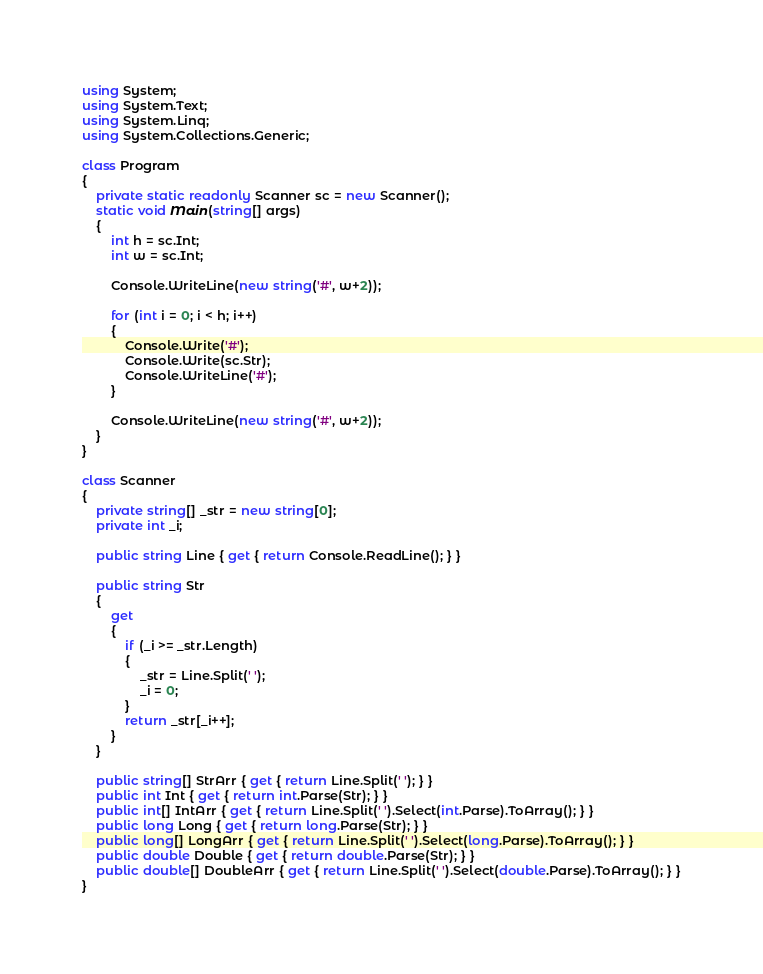<code> <loc_0><loc_0><loc_500><loc_500><_C#_>using System;
using System.Text;
using System.Linq;
using System.Collections.Generic;

class Program
{
    private static readonly Scanner sc = new Scanner();
    static void Main(string[] args)
    {
        int h = sc.Int;
        int w = sc.Int;

        Console.WriteLine(new string('#', w+2));

        for (int i = 0; i < h; i++)
        {
            Console.Write('#');
            Console.Write(sc.Str);
            Console.WriteLine('#');
        }

        Console.WriteLine(new string('#', w+2));
    }
}

class Scanner
{
    private string[] _str = new string[0];
    private int _i;

    public string Line { get { return Console.ReadLine(); } }

    public string Str
    {
        get
        {
            if (_i >= _str.Length)
            {
                _str = Line.Split(' ');
                _i = 0;
            }
            return _str[_i++];
        }
    }

    public string[] StrArr { get { return Line.Split(' '); } }
    public int Int { get { return int.Parse(Str); } }
    public int[] IntArr { get { return Line.Split(' ').Select(int.Parse).ToArray(); } }
    public long Long { get { return long.Parse(Str); } }
    public long[] LongArr { get { return Line.Split(' ').Select(long.Parse).ToArray(); } }
    public double Double { get { return double.Parse(Str); } }
    public double[] DoubleArr { get { return Line.Split(' ').Select(double.Parse).ToArray(); } }
}</code> 